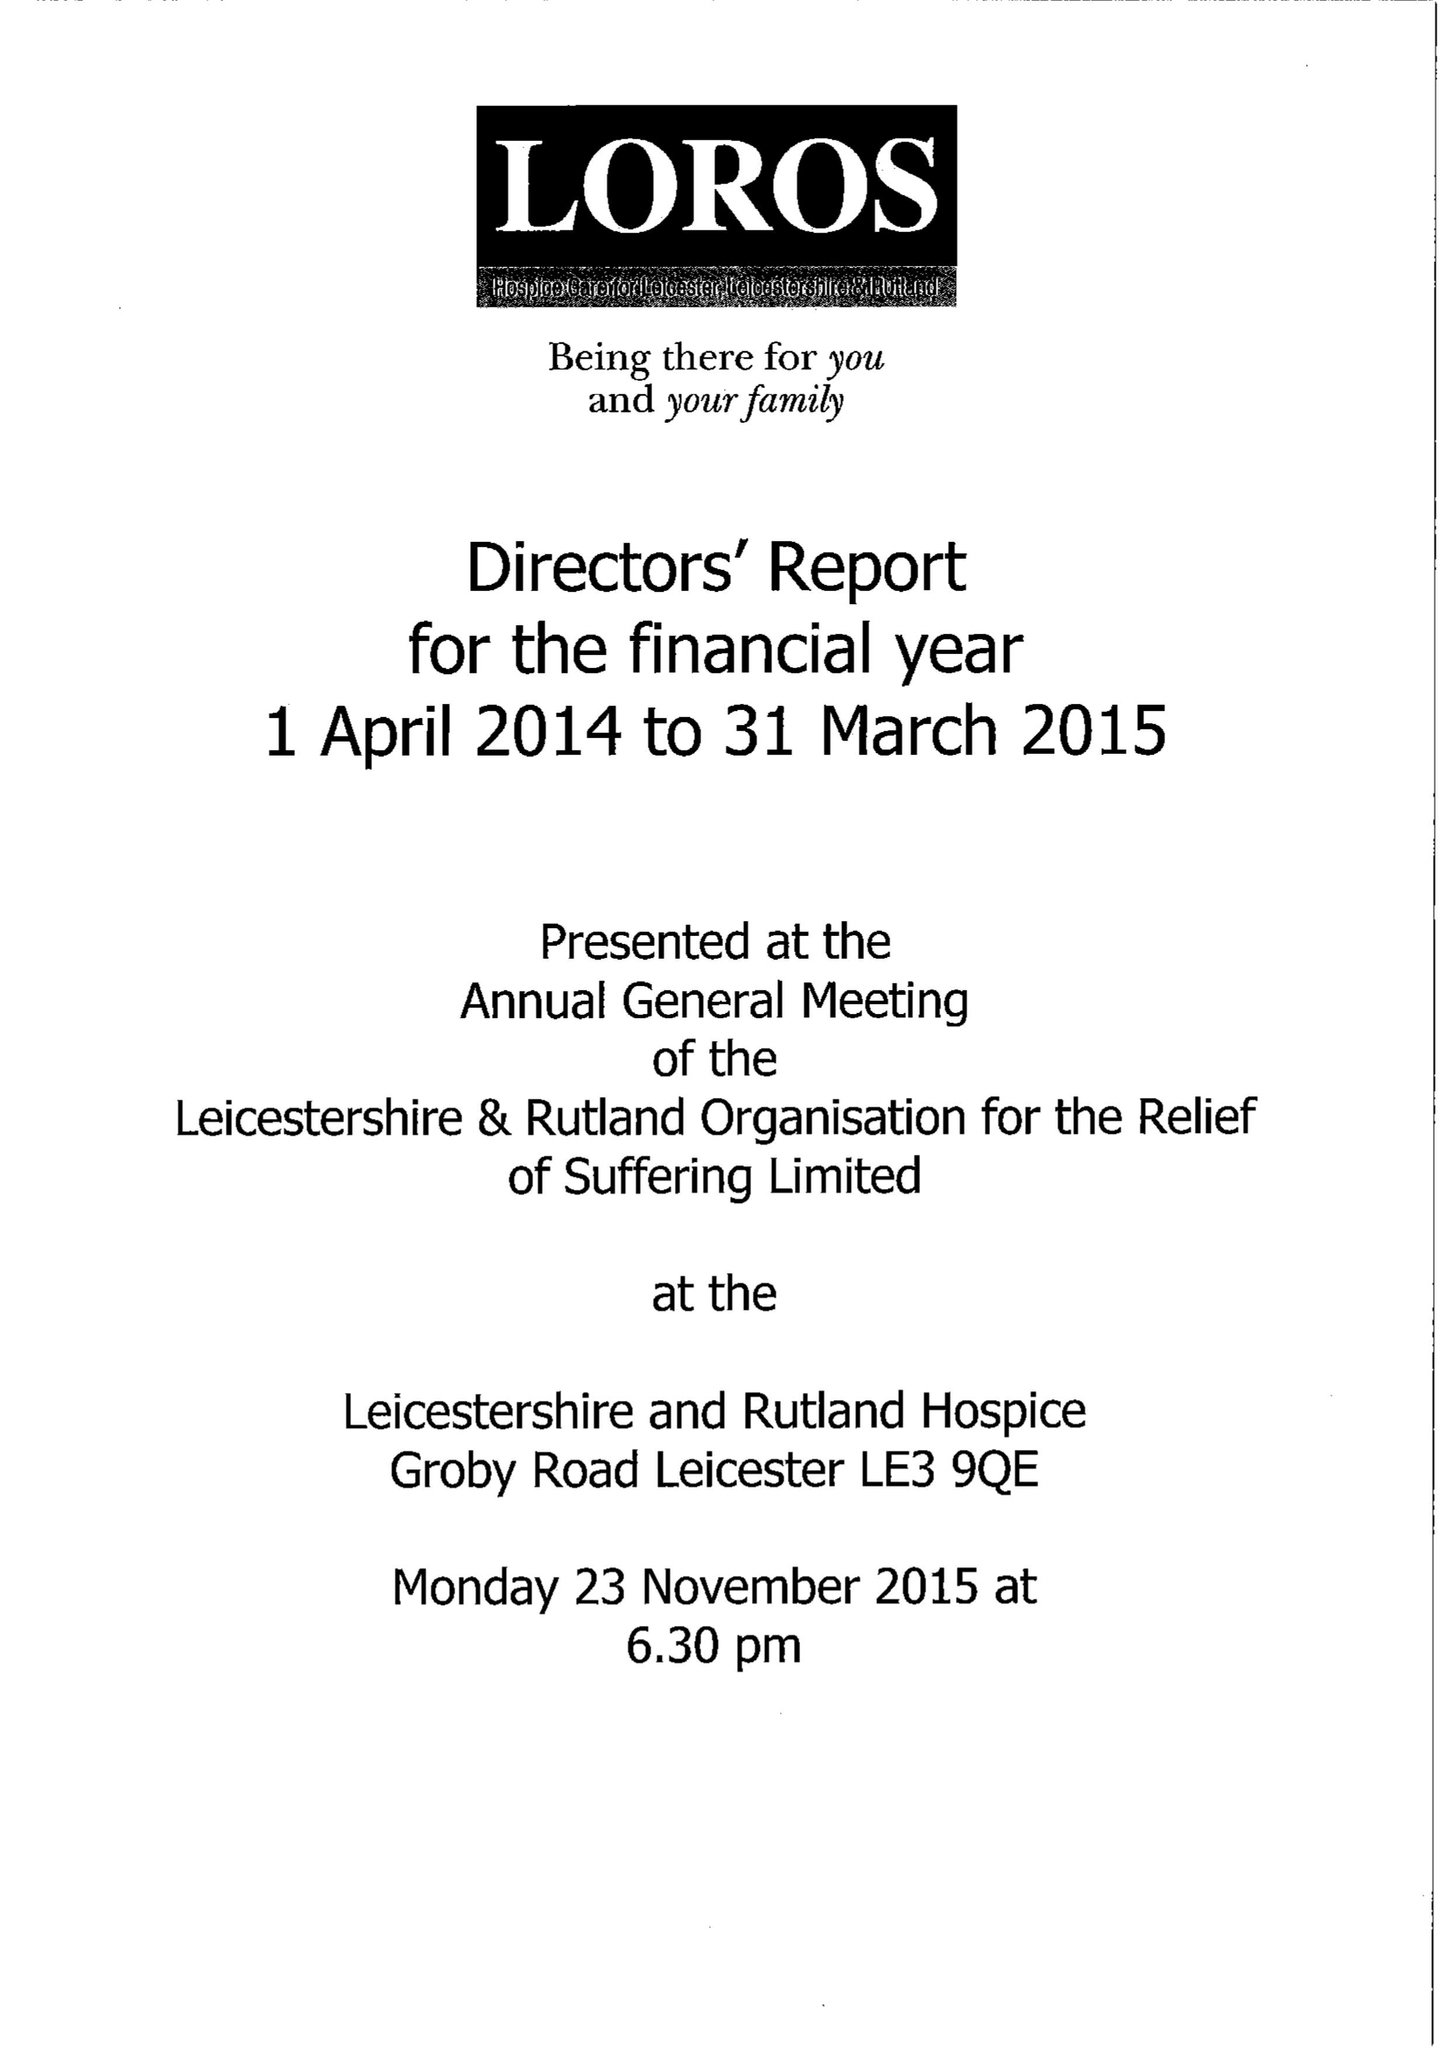What is the value for the income_annually_in_british_pounds?
Answer the question using a single word or phrase. 11189023.00 